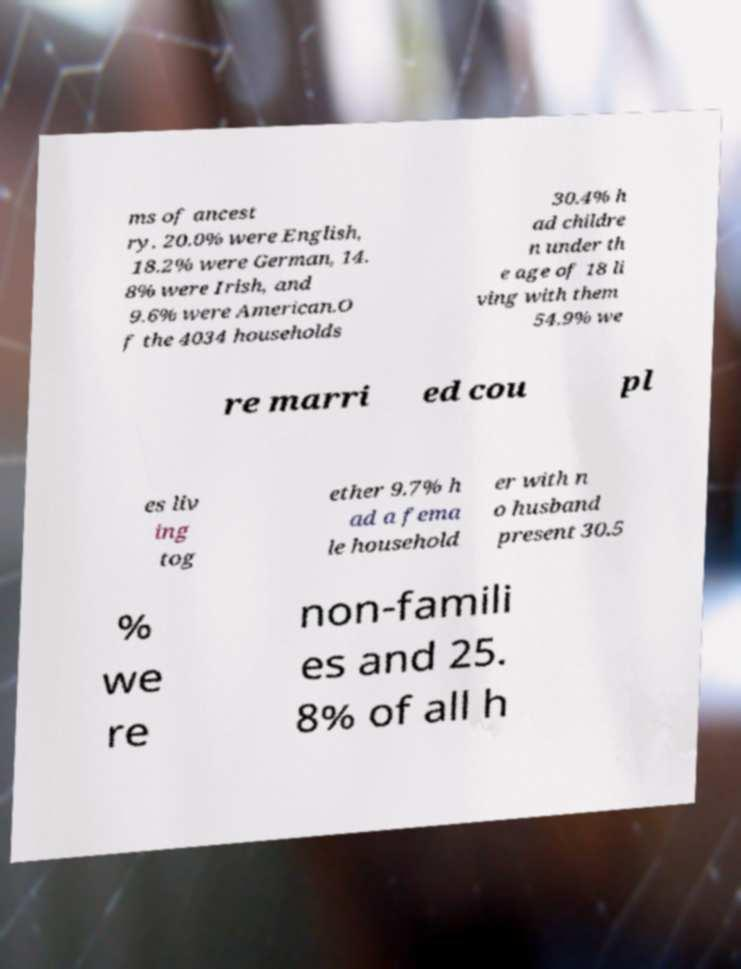There's text embedded in this image that I need extracted. Can you transcribe it verbatim? ms of ancest ry, 20.0% were English, 18.2% were German, 14. 8% were Irish, and 9.6% were American.O f the 4034 households 30.4% h ad childre n under th e age of 18 li ving with them 54.9% we re marri ed cou pl es liv ing tog ether 9.7% h ad a fema le household er with n o husband present 30.5 % we re non-famili es and 25. 8% of all h 